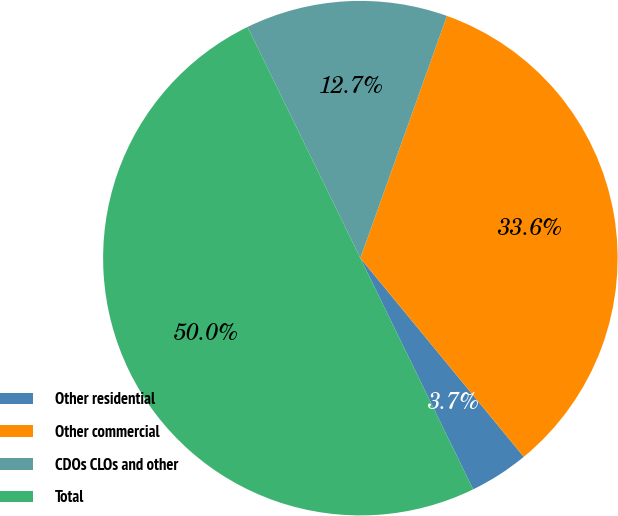Convert chart to OTSL. <chart><loc_0><loc_0><loc_500><loc_500><pie_chart><fcel>Other residential<fcel>Other commercial<fcel>CDOs CLOs and other<fcel>Total<nl><fcel>3.73%<fcel>33.58%<fcel>12.69%<fcel>50.0%<nl></chart> 